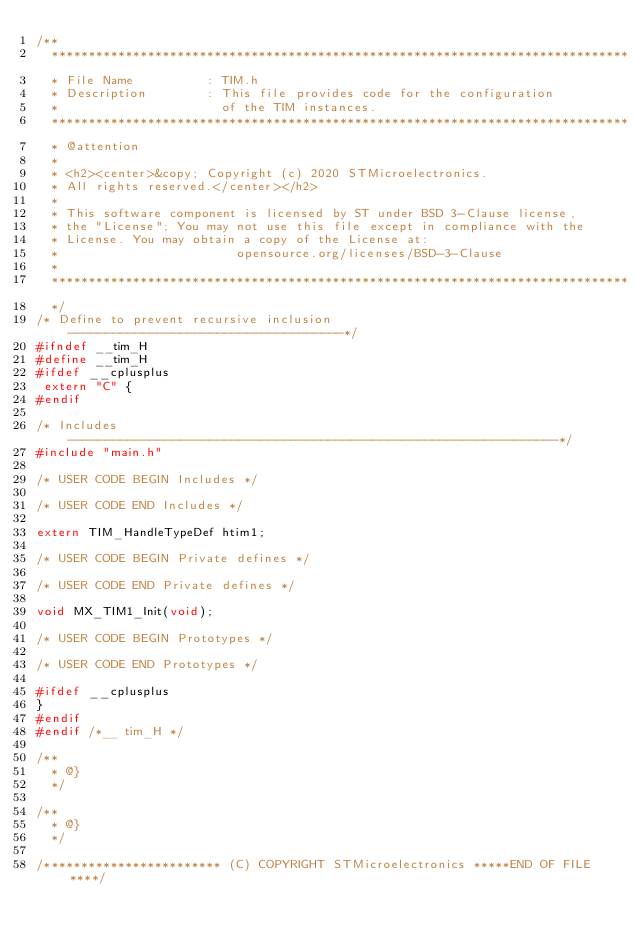Convert code to text. <code><loc_0><loc_0><loc_500><loc_500><_C_>/**
  ******************************************************************************
  * File Name          : TIM.h
  * Description        : This file provides code for the configuration
  *                      of the TIM instances.
  ******************************************************************************
  * @attention
  *
  * <h2><center>&copy; Copyright (c) 2020 STMicroelectronics.
  * All rights reserved.</center></h2>
  *
  * This software component is licensed by ST under BSD 3-Clause license,
  * the "License"; You may not use this file except in compliance with the
  * License. You may obtain a copy of the License at:
  *                        opensource.org/licenses/BSD-3-Clause
  *
  ******************************************************************************
  */
/* Define to prevent recursive inclusion -------------------------------------*/
#ifndef __tim_H
#define __tim_H
#ifdef __cplusplus
 extern "C" {
#endif

/* Includes ------------------------------------------------------------------*/
#include "main.h"

/* USER CODE BEGIN Includes */

/* USER CODE END Includes */

extern TIM_HandleTypeDef htim1;

/* USER CODE BEGIN Private defines */

/* USER CODE END Private defines */

void MX_TIM1_Init(void);

/* USER CODE BEGIN Prototypes */

/* USER CODE END Prototypes */

#ifdef __cplusplus
}
#endif
#endif /*__ tim_H */

/**
  * @}
  */

/**
  * @}
  */

/************************ (C) COPYRIGHT STMicroelectronics *****END OF FILE****/
</code> 